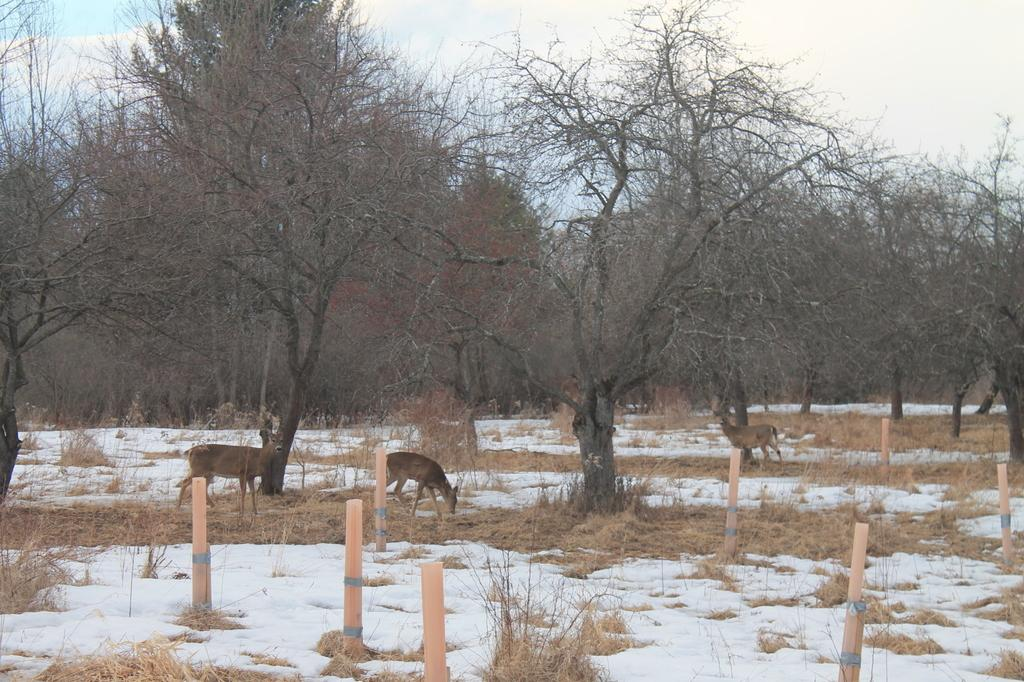What type of animals can be seen on the ground in the image? There are animals on the ground in the image. What else can be seen in the image besides the animals? There are poles, grass, a group of trees, and the sky visible in the image. Can you describe the vegetation in the image? There is grass and a group of trees in the image. What is visible in the background of the image? The sky is visible in the image. How many clocks are hanging from the poles in the image? There are no clocks visible in the image; only animals, poles, grass, trees, and the sky can be seen. 